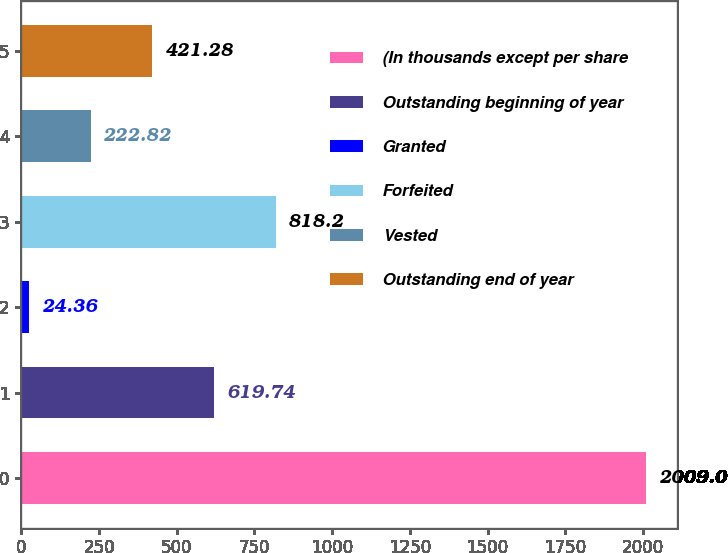Convert chart to OTSL. <chart><loc_0><loc_0><loc_500><loc_500><bar_chart><fcel>(In thousands except per share<fcel>Outstanding beginning of year<fcel>Granted<fcel>Forfeited<fcel>Vested<fcel>Outstanding end of year<nl><fcel>2009<fcel>619.74<fcel>24.36<fcel>818.2<fcel>222.82<fcel>421.28<nl></chart> 